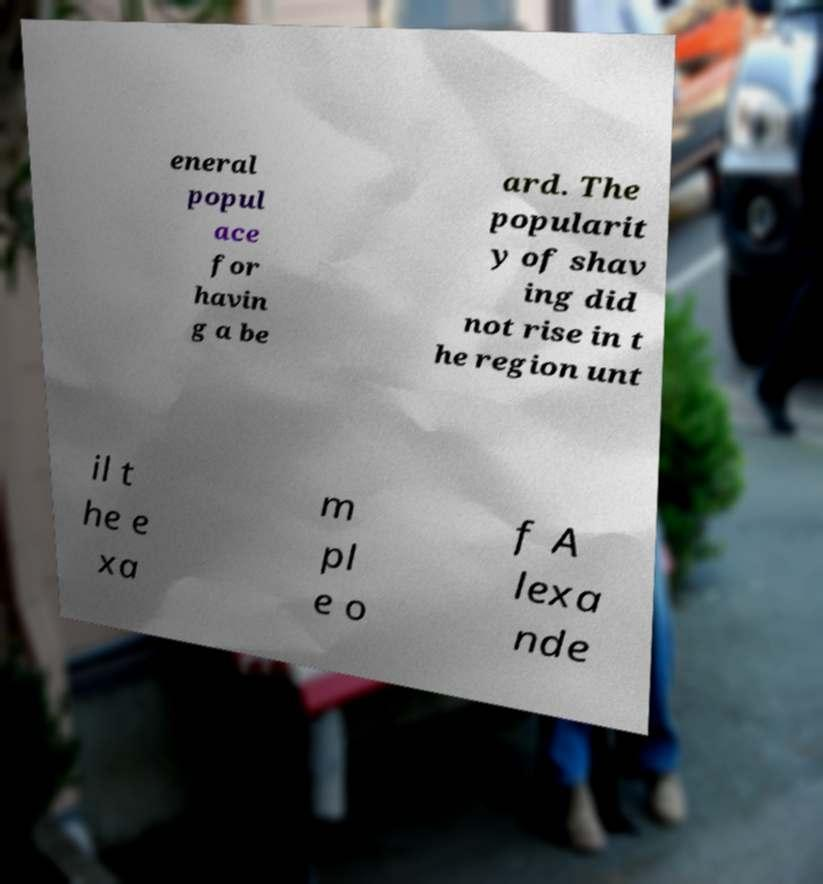Could you assist in decoding the text presented in this image and type it out clearly? eneral popul ace for havin g a be ard. The popularit y of shav ing did not rise in t he region unt il t he e xa m pl e o f A lexa nde 